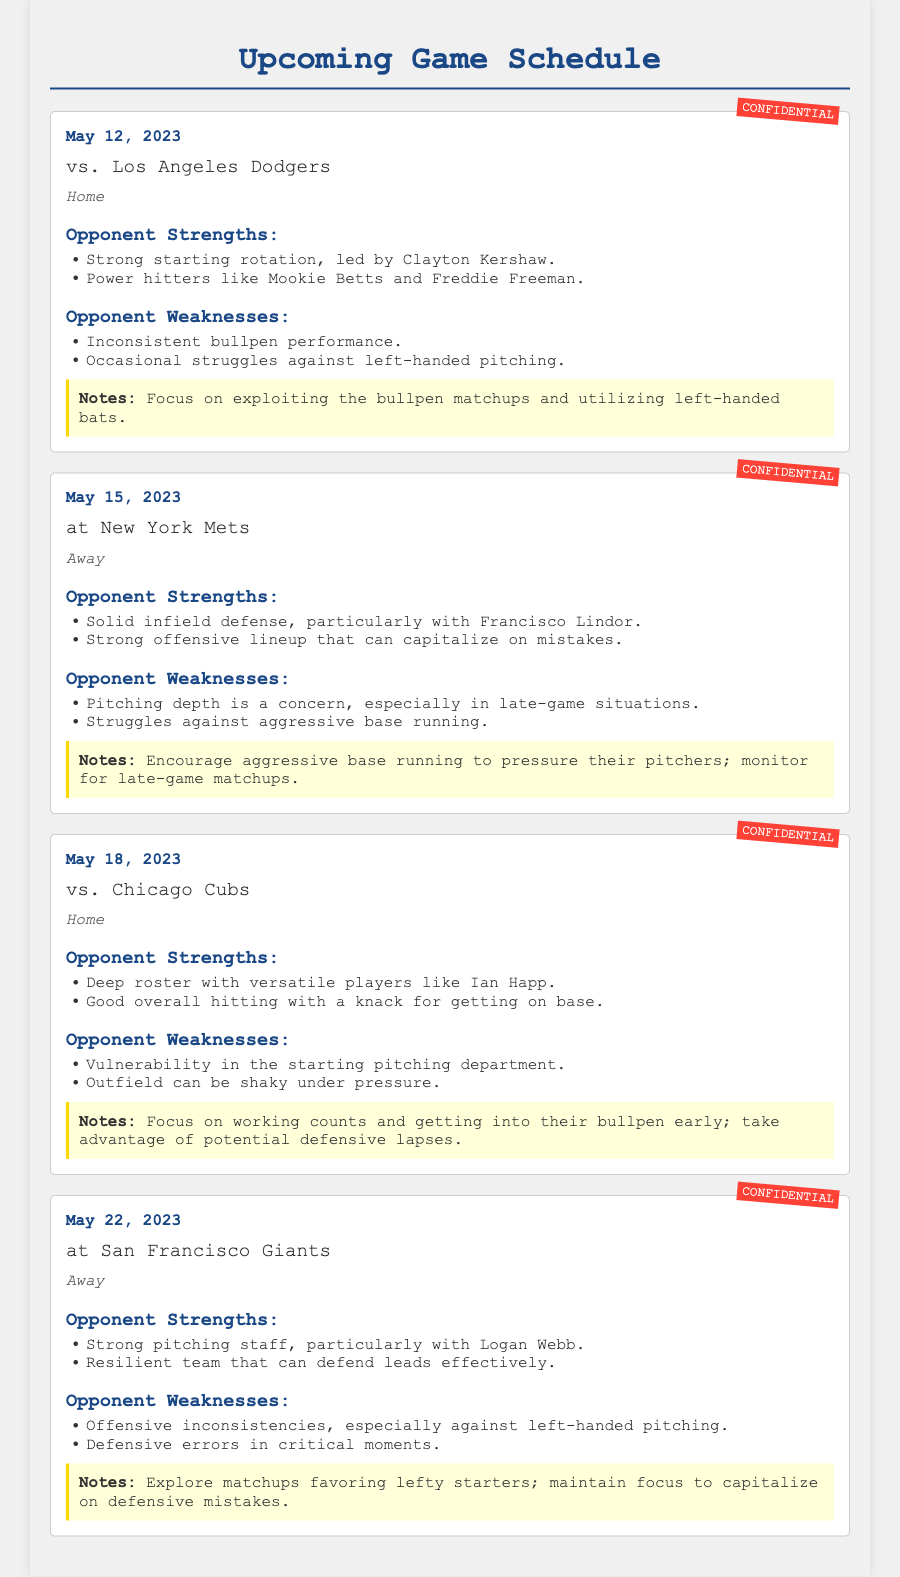What is the date of the game against the Los Angeles Dodgers? The game against the Los Angeles Dodgers is scheduled for May 12, 2023.
Answer: May 12, 2023 What is a strength of the New York Mets? One strength of the New York Mets is their strong offensive lineup that can capitalize on mistakes.
Answer: Strong offensive lineup What is a noted weakness of the Chicago Cubs? The Chicago Cubs have a noted weakness in their starting pitching department.
Answer: Vulnerability in starting pitching What is the location for the game on May 18, 2023? The game on May 18, 2023, against the Chicago Cubs is set to take place at home.
Answer: Home Which pitcher leads the strong starting rotation of the Los Angeles Dodgers? Clayton Kershaw leads the strong starting rotation of the Los Angeles Dodgers.
Answer: Clayton Kershaw What should be exploited against the Los Angeles Dodgers? The focus should be on exploiting the bullpen matchups against the Los Angeles Dodgers.
Answer: Bullpen matchups Which team has solid infield defense? The New York Mets have solid infield defense, particularly with Francisco Lindor.
Answer: New York Mets What is a strategy to use against the San Francisco Giants? A strategy is to exploit matchups favoring lefty starters against the San Francisco Giants.
Answer: Matchups favoring lefty starters What is a weakness identified for the San Francisco Giants? A weakness of the San Francisco Giants is their offensive inconsistencies, especially against left-handed pitching.
Answer: Offensive inconsistencies 